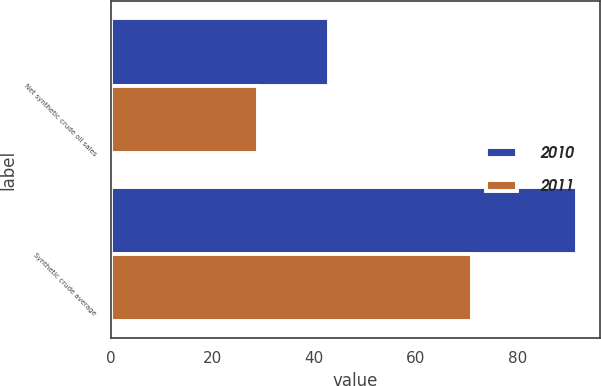Convert chart. <chart><loc_0><loc_0><loc_500><loc_500><stacked_bar_chart><ecel><fcel>Net synthetic crude oil sales<fcel>Synthetic crude average<nl><fcel>2010<fcel>43<fcel>91.65<nl><fcel>2011<fcel>29<fcel>71.06<nl></chart> 